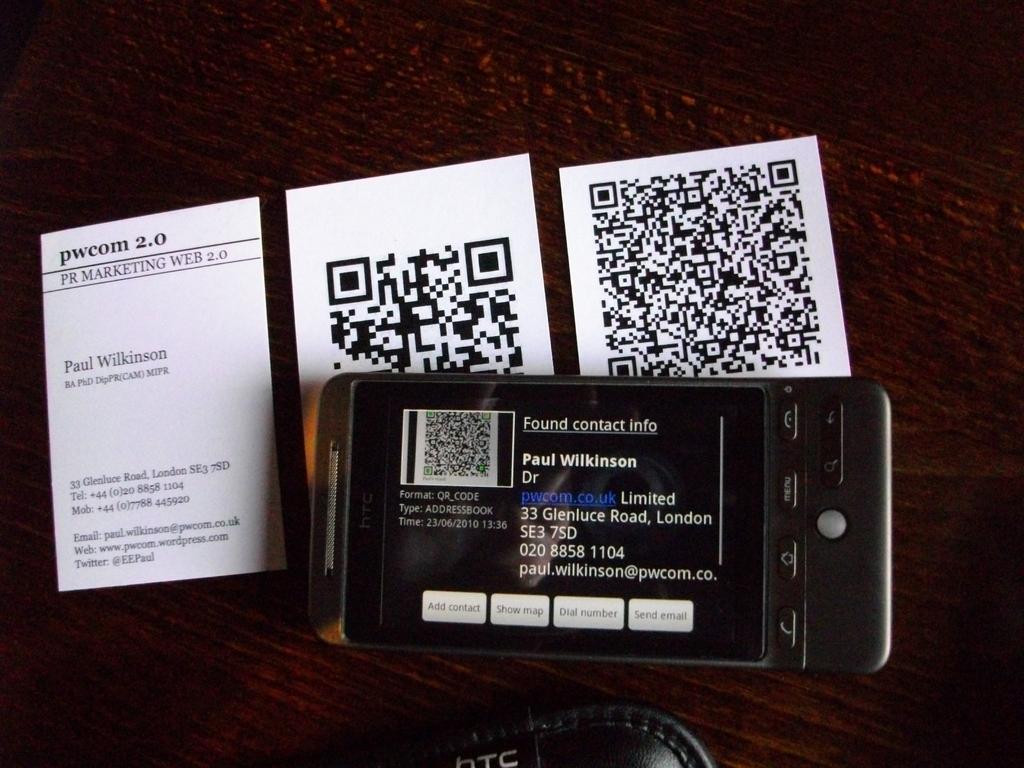Whose name is on the contact info for the phone?
Keep it short and to the point. Paul wilkinson. What is paul wilkinson's email address?
Provide a succinct answer. Paul.wilkinson@pwcom.co. 